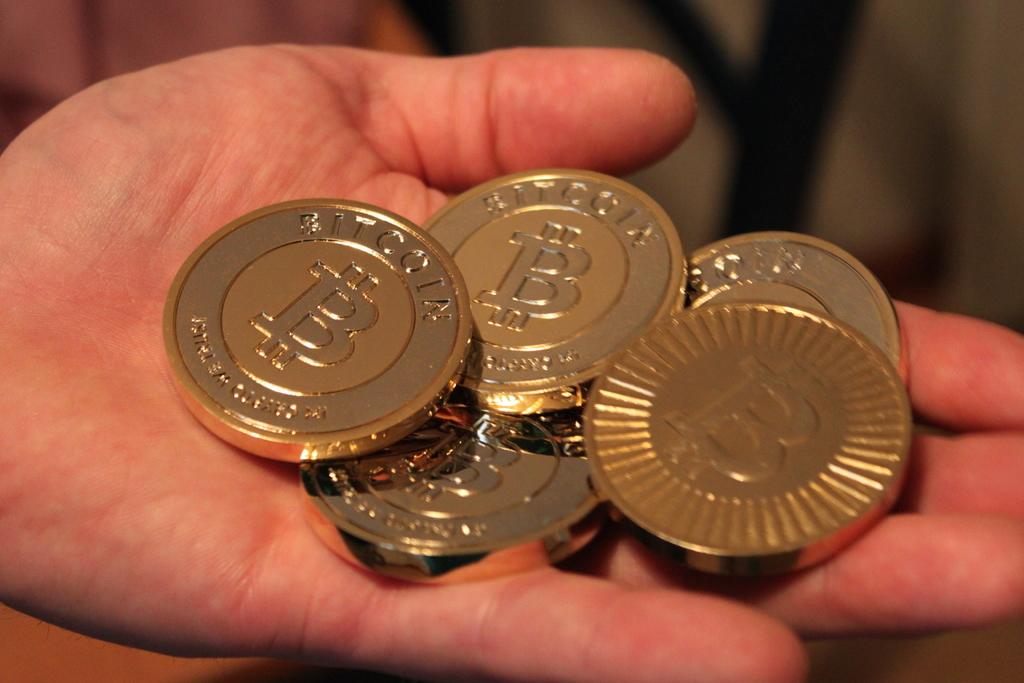<image>
Give a short and clear explanation of the subsequent image. A quintet of Bitcoin tokens sit in a person's open palm. 